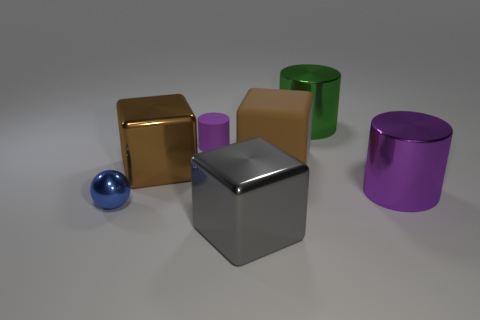Does the metallic block that is behind the large purple thing have the same color as the large matte thing?
Offer a very short reply. Yes. What color is the cylinder that is on the left side of the large purple metallic object and in front of the large green metallic object?
Give a very brief answer. Purple. What is the shape of the purple object that is the same size as the blue object?
Your response must be concise. Cylinder. Is there a green thing of the same shape as the brown metal thing?
Offer a very short reply. No. There is a object on the right side of the green cylinder; is its size the same as the small purple rubber cylinder?
Your answer should be very brief. No. There is a cylinder that is right of the gray thing and on the left side of the big purple cylinder; how big is it?
Provide a succinct answer. Large. What number of other objects are there of the same material as the small blue sphere?
Keep it short and to the point. 4. There is a purple thing that is in front of the tiny cylinder; what size is it?
Your answer should be compact. Large. How many large objects are matte blocks or cyan rubber balls?
Provide a short and direct response. 1. Is there anything else of the same color as the small metallic object?
Keep it short and to the point. No. 